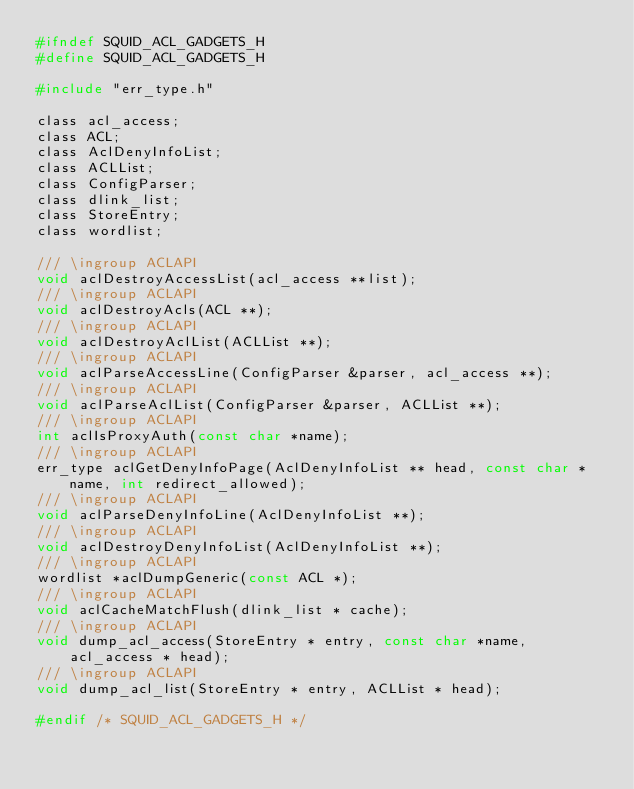Convert code to text. <code><loc_0><loc_0><loc_500><loc_500><_C_>#ifndef SQUID_ACL_GADGETS_H
#define SQUID_ACL_GADGETS_H

#include "err_type.h"

class acl_access;
class ACL;
class AclDenyInfoList;
class ACLList;
class ConfigParser;
class dlink_list;
class StoreEntry;
class wordlist;

/// \ingroup ACLAPI
void aclDestroyAccessList(acl_access **list);
/// \ingroup ACLAPI
void aclDestroyAcls(ACL **);
/// \ingroup ACLAPI
void aclDestroyAclList(ACLList **);
/// \ingroup ACLAPI
void aclParseAccessLine(ConfigParser &parser, acl_access **);
/// \ingroup ACLAPI
void aclParseAclList(ConfigParser &parser, ACLList **);
/// \ingroup ACLAPI
int aclIsProxyAuth(const char *name);
/// \ingroup ACLAPI
err_type aclGetDenyInfoPage(AclDenyInfoList ** head, const char *name, int redirect_allowed);
/// \ingroup ACLAPI
void aclParseDenyInfoLine(AclDenyInfoList **);
/// \ingroup ACLAPI
void aclDestroyDenyInfoList(AclDenyInfoList **);
/// \ingroup ACLAPI
wordlist *aclDumpGeneric(const ACL *);
/// \ingroup ACLAPI
void aclCacheMatchFlush(dlink_list * cache);
/// \ingroup ACLAPI
void dump_acl_access(StoreEntry * entry, const char *name, acl_access * head);
/// \ingroup ACLAPI
void dump_acl_list(StoreEntry * entry, ACLList * head);

#endif /* SQUID_ACL_GADGETS_H */
</code> 